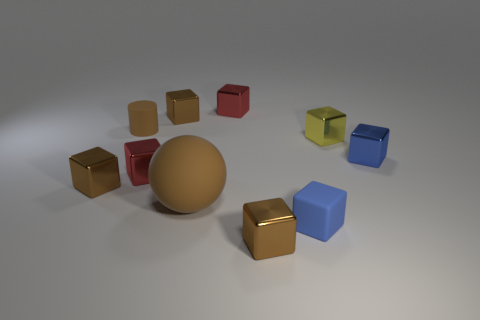Is there anything else that has the same size as the matte ball?
Your response must be concise. No. Are there any other things that are the same shape as the large thing?
Make the answer very short. No. There is a yellow object that is the same shape as the tiny blue matte thing; what is its material?
Your response must be concise. Metal. How many other objects are there of the same size as the brown cylinder?
Offer a terse response. 8. The object that is the same color as the tiny rubber block is what size?
Offer a very short reply. Small. Is the shape of the brown matte thing that is on the right side of the tiny brown rubber cylinder the same as  the blue matte object?
Ensure brevity in your answer.  No. How many other objects are the same shape as the big rubber thing?
Keep it short and to the point. 0. What is the shape of the brown rubber thing that is in front of the tiny yellow metal cube?
Your answer should be compact. Sphere. Are there any small red blocks that have the same material as the brown ball?
Offer a terse response. No. Is the color of the tiny rubber thing that is behind the tiny yellow metal cube the same as the large matte ball?
Ensure brevity in your answer.  Yes. 